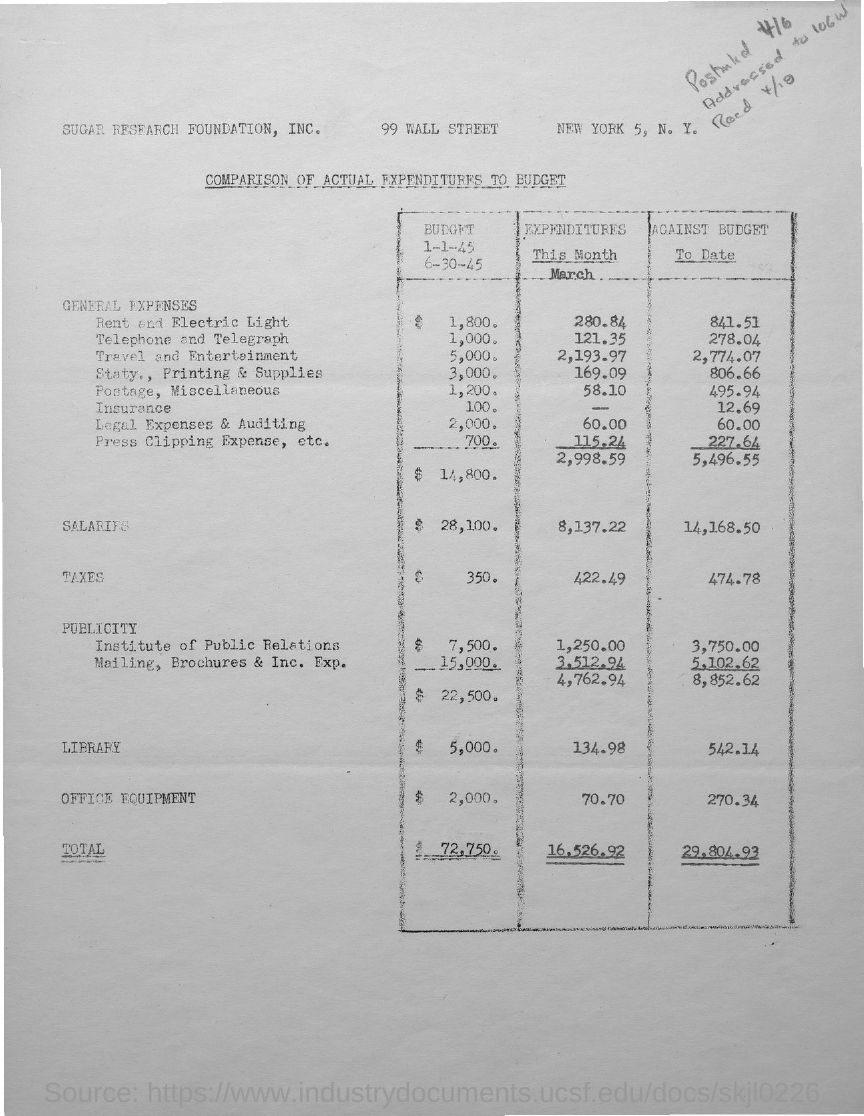What is the salary expenditure for the month of March?
Make the answer very short. 8,137.22. What is the amount of tax against the budget to date?
Make the answer very short. 474.78. What is the total expenditure for the month of march?
Offer a very short reply. 16,526.92. What type of comparison is given in this document?
Your answer should be compact. Comparison of actual expenditures to budget. What is the total amount of general expenses against the budget to date?
Your answer should be compact. 5,496.55. What is the amount of general expenses for the month of march?
Your answer should be compact. 2,998.59. What is the amount of salaries against the budget to date?
Offer a terse response. 14,168.50. 